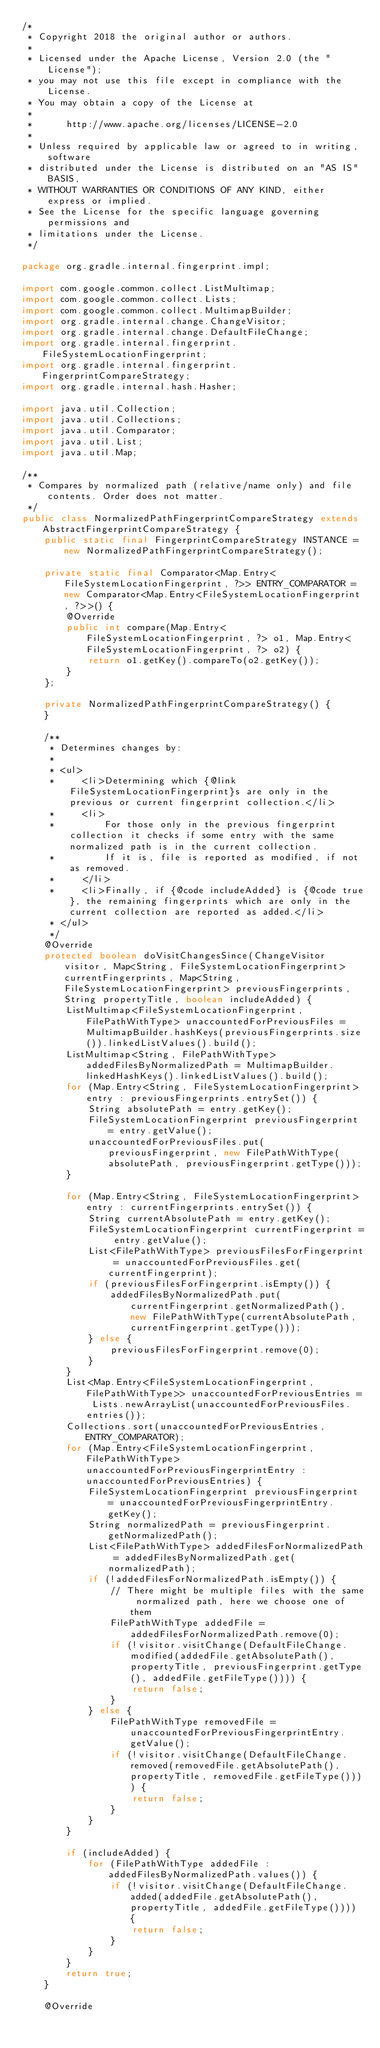Convert code to text. <code><loc_0><loc_0><loc_500><loc_500><_Java_>/*
 * Copyright 2018 the original author or authors.
 *
 * Licensed under the Apache License, Version 2.0 (the "License");
 * you may not use this file except in compliance with the License.
 * You may obtain a copy of the License at
 *
 *      http://www.apache.org/licenses/LICENSE-2.0
 *
 * Unless required by applicable law or agreed to in writing, software
 * distributed under the License is distributed on an "AS IS" BASIS,
 * WITHOUT WARRANTIES OR CONDITIONS OF ANY KIND, either express or implied.
 * See the License for the specific language governing permissions and
 * limitations under the License.
 */

package org.gradle.internal.fingerprint.impl;

import com.google.common.collect.ListMultimap;
import com.google.common.collect.Lists;
import com.google.common.collect.MultimapBuilder;
import org.gradle.internal.change.ChangeVisitor;
import org.gradle.internal.change.DefaultFileChange;
import org.gradle.internal.fingerprint.FileSystemLocationFingerprint;
import org.gradle.internal.fingerprint.FingerprintCompareStrategy;
import org.gradle.internal.hash.Hasher;

import java.util.Collection;
import java.util.Collections;
import java.util.Comparator;
import java.util.List;
import java.util.Map;

/**
 * Compares by normalized path (relative/name only) and file contents. Order does not matter.
 */
public class NormalizedPathFingerprintCompareStrategy extends AbstractFingerprintCompareStrategy {
    public static final FingerprintCompareStrategy INSTANCE = new NormalizedPathFingerprintCompareStrategy();

    private static final Comparator<Map.Entry<FileSystemLocationFingerprint, ?>> ENTRY_COMPARATOR = new Comparator<Map.Entry<FileSystemLocationFingerprint, ?>>() {
        @Override
        public int compare(Map.Entry<FileSystemLocationFingerprint, ?> o1, Map.Entry<FileSystemLocationFingerprint, ?> o2) {
            return o1.getKey().compareTo(o2.getKey());
        }
    };

    private NormalizedPathFingerprintCompareStrategy() {
    }

    /**
     * Determines changes by:
     *
     * <ul>
     *     <li>Determining which {@link FileSystemLocationFingerprint}s are only in the previous or current fingerprint collection.</li>
     *     <li>
     *         For those only in the previous fingerprint collection it checks if some entry with the same normalized path is in the current collection.
     *         If it is, file is reported as modified, if not as removed.
     *     </li>
     *     <li>Finally, if {@code includeAdded} is {@code true}, the remaining fingerprints which are only in the current collection are reported as added.</li>
     * </ul>
     */
    @Override
    protected boolean doVisitChangesSince(ChangeVisitor visitor, Map<String, FileSystemLocationFingerprint> currentFingerprints, Map<String, FileSystemLocationFingerprint> previousFingerprints, String propertyTitle, boolean includeAdded) {
        ListMultimap<FileSystemLocationFingerprint, FilePathWithType> unaccountedForPreviousFiles = MultimapBuilder.hashKeys(previousFingerprints.size()).linkedListValues().build();
        ListMultimap<String, FilePathWithType> addedFilesByNormalizedPath = MultimapBuilder.linkedHashKeys().linkedListValues().build();
        for (Map.Entry<String, FileSystemLocationFingerprint> entry : previousFingerprints.entrySet()) {
            String absolutePath = entry.getKey();
            FileSystemLocationFingerprint previousFingerprint = entry.getValue();
            unaccountedForPreviousFiles.put(previousFingerprint, new FilePathWithType(absolutePath, previousFingerprint.getType()));
        }

        for (Map.Entry<String, FileSystemLocationFingerprint> entry : currentFingerprints.entrySet()) {
            String currentAbsolutePath = entry.getKey();
            FileSystemLocationFingerprint currentFingerprint = entry.getValue();
            List<FilePathWithType> previousFilesForFingerprint = unaccountedForPreviousFiles.get(currentFingerprint);
            if (previousFilesForFingerprint.isEmpty()) {
                addedFilesByNormalizedPath.put(currentFingerprint.getNormalizedPath(), new FilePathWithType(currentAbsolutePath, currentFingerprint.getType()));
            } else {
                previousFilesForFingerprint.remove(0);
            }
        }
        List<Map.Entry<FileSystemLocationFingerprint, FilePathWithType>> unaccountedForPreviousEntries = Lists.newArrayList(unaccountedForPreviousFiles.entries());
        Collections.sort(unaccountedForPreviousEntries, ENTRY_COMPARATOR);
        for (Map.Entry<FileSystemLocationFingerprint, FilePathWithType> unaccountedForPreviousFingerprintEntry : unaccountedForPreviousEntries) {
            FileSystemLocationFingerprint previousFingerprint = unaccountedForPreviousFingerprintEntry.getKey();
            String normalizedPath = previousFingerprint.getNormalizedPath();
            List<FilePathWithType> addedFilesForNormalizedPath = addedFilesByNormalizedPath.get(normalizedPath);
            if (!addedFilesForNormalizedPath.isEmpty()) {
                // There might be multiple files with the same normalized path, here we choose one of them
                FilePathWithType addedFile = addedFilesForNormalizedPath.remove(0);
                if (!visitor.visitChange(DefaultFileChange.modified(addedFile.getAbsolutePath(), propertyTitle, previousFingerprint.getType(), addedFile.getFileType()))) {
                    return false;
                }
            } else {
                FilePathWithType removedFile = unaccountedForPreviousFingerprintEntry.getValue();
                if (!visitor.visitChange(DefaultFileChange.removed(removedFile.getAbsolutePath(), propertyTitle, removedFile.getFileType()))) {
                    return false;
                }
            }
        }

        if (includeAdded) {
            for (FilePathWithType addedFile : addedFilesByNormalizedPath.values()) {
                if (!visitor.visitChange(DefaultFileChange.added(addedFile.getAbsolutePath(), propertyTitle, addedFile.getFileType()))) {
                    return false;
                }
            }
        }
        return true;
    }

    @Override</code> 